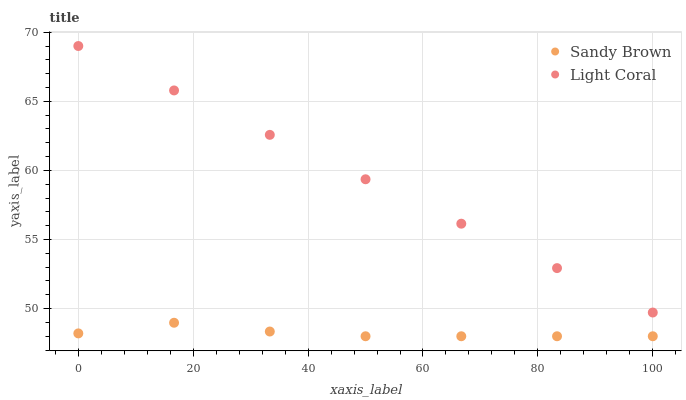Does Sandy Brown have the minimum area under the curve?
Answer yes or no. Yes. Does Light Coral have the maximum area under the curve?
Answer yes or no. Yes. Does Sandy Brown have the maximum area under the curve?
Answer yes or no. No. Is Light Coral the smoothest?
Answer yes or no. Yes. Is Sandy Brown the roughest?
Answer yes or no. Yes. Is Sandy Brown the smoothest?
Answer yes or no. No. Does Sandy Brown have the lowest value?
Answer yes or no. Yes. Does Light Coral have the highest value?
Answer yes or no. Yes. Does Sandy Brown have the highest value?
Answer yes or no. No. Is Sandy Brown less than Light Coral?
Answer yes or no. Yes. Is Light Coral greater than Sandy Brown?
Answer yes or no. Yes. Does Sandy Brown intersect Light Coral?
Answer yes or no. No. 